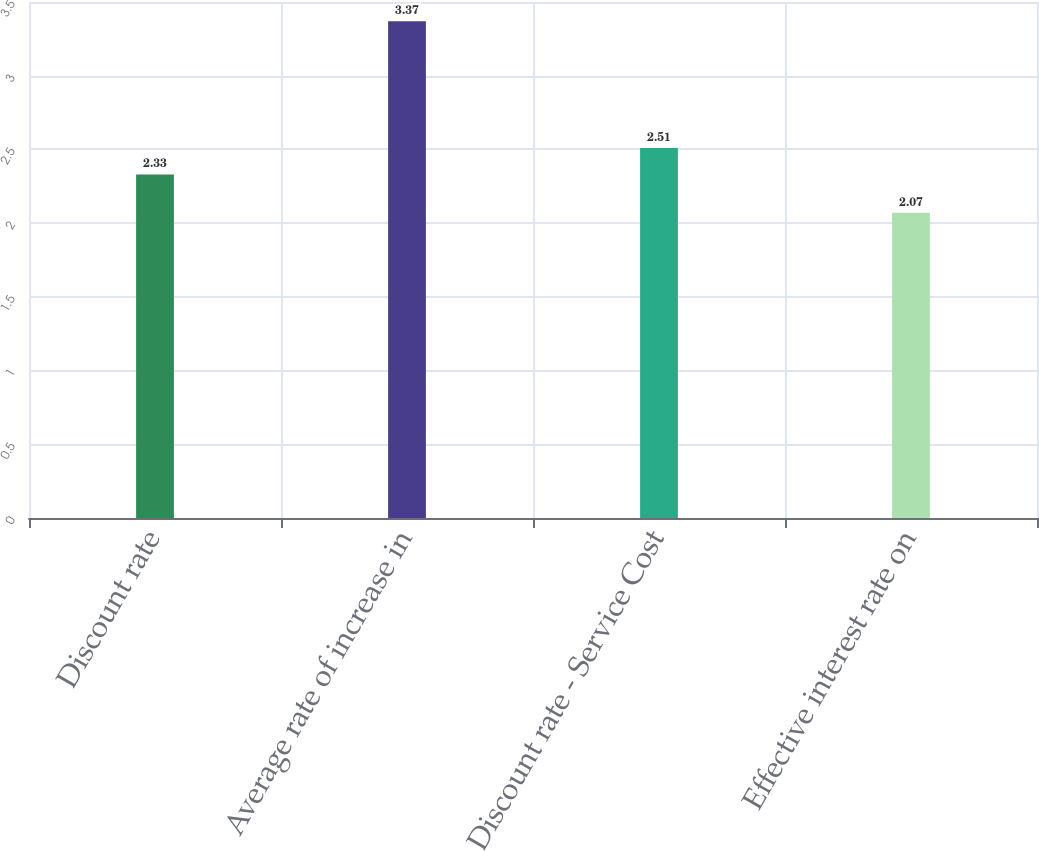Convert chart to OTSL. <chart><loc_0><loc_0><loc_500><loc_500><bar_chart><fcel>Discount rate<fcel>Average rate of increase in<fcel>Discount rate - Service Cost<fcel>Effective interest rate on<nl><fcel>2.33<fcel>3.37<fcel>2.51<fcel>2.07<nl></chart> 